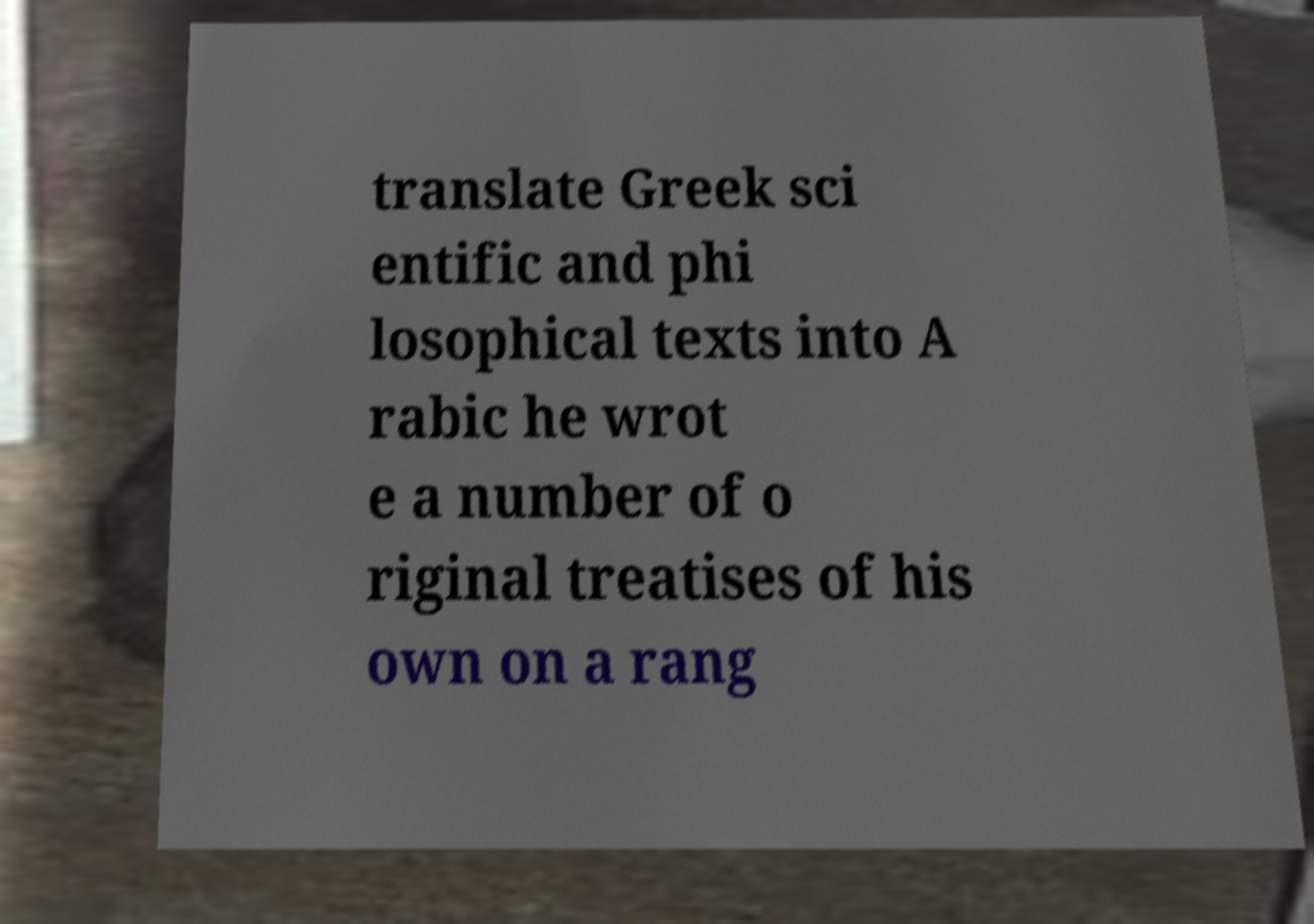Could you assist in decoding the text presented in this image and type it out clearly? translate Greek sci entific and phi losophical texts into A rabic he wrot e a number of o riginal treatises of his own on a rang 